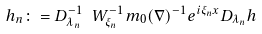Convert formula to latex. <formula><loc_0><loc_0><loc_500><loc_500>h _ { n } \colon = D _ { \lambda _ { n } } ^ { - 1 } \ W _ { \xi _ { n } } ^ { - 1 } m _ { 0 } ( \nabla ) ^ { - 1 } e ^ { i \xi _ { n } x } D _ { \lambda _ { n } } h</formula> 